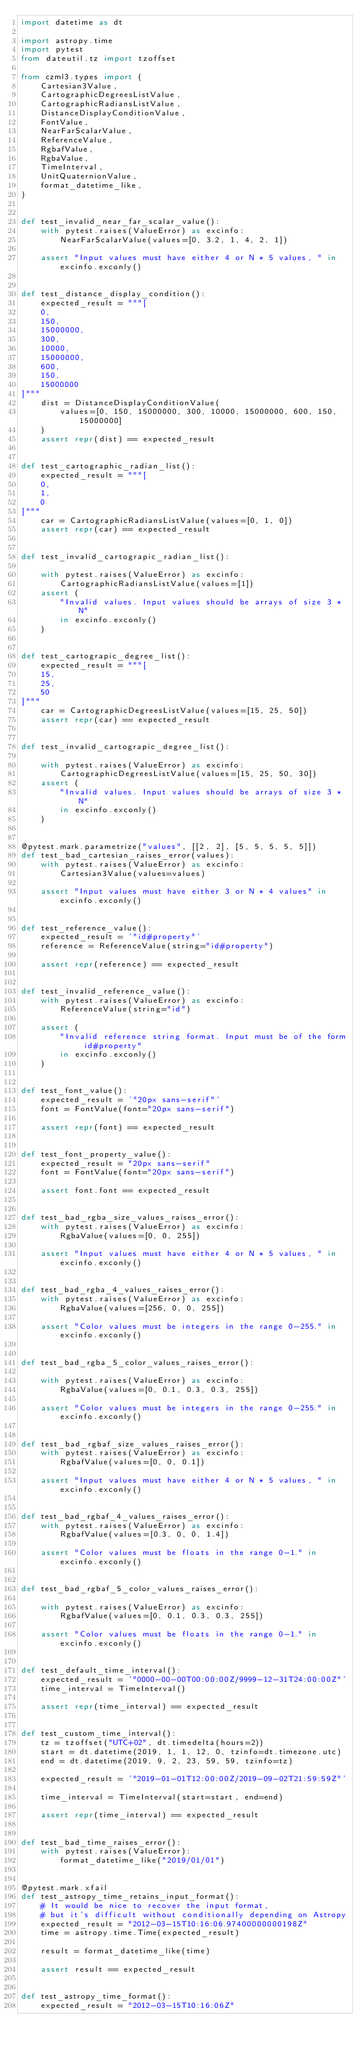Convert code to text. <code><loc_0><loc_0><loc_500><loc_500><_Python_>import datetime as dt

import astropy.time
import pytest
from dateutil.tz import tzoffset

from czml3.types import (
    Cartesian3Value,
    CartographicDegreesListValue,
    CartographicRadiansListValue,
    DistanceDisplayConditionValue,
    FontValue,
    NearFarScalarValue,
    ReferenceValue,
    RgbafValue,
    RgbaValue,
    TimeInterval,
    UnitQuaternionValue,
    format_datetime_like,
)


def test_invalid_near_far_scalar_value():
    with pytest.raises(ValueError) as excinfo:
        NearFarScalarValue(values=[0, 3.2, 1, 4, 2, 1])

    assert "Input values must have either 4 or N * 5 values, " in excinfo.exconly()


def test_distance_display_condition():
    expected_result = """[
    0,
    150,
    15000000,
    300,
    10000,
    15000000,
    600,
    150,
    15000000
]"""
    dist = DistanceDisplayConditionValue(
        values=[0, 150, 15000000, 300, 10000, 15000000, 600, 150, 15000000]
    )
    assert repr(dist) == expected_result


def test_cartographic_radian_list():
    expected_result = """[
    0,
    1,
    0
]"""
    car = CartographicRadiansListValue(values=[0, 1, 0])
    assert repr(car) == expected_result


def test_invalid_cartograpic_radian_list():

    with pytest.raises(ValueError) as excinfo:
        CartographicRadiansListValue(values=[1])
    assert (
        "Invalid values. Input values should be arrays of size 3 * N"
        in excinfo.exconly()
    )


def test_cartograpic_degree_list():
    expected_result = """[
    15,
    25,
    50
]"""
    car = CartographicDegreesListValue(values=[15, 25, 50])
    assert repr(car) == expected_result


def test_invalid_cartograpic_degree_list():

    with pytest.raises(ValueError) as excinfo:
        CartographicDegreesListValue(values=[15, 25, 50, 30])
    assert (
        "Invalid values. Input values should be arrays of size 3 * N"
        in excinfo.exconly()
    )


@pytest.mark.parametrize("values", [[2, 2], [5, 5, 5, 5, 5]])
def test_bad_cartesian_raises_error(values):
    with pytest.raises(ValueError) as excinfo:
        Cartesian3Value(values=values)

    assert "Input values must have either 3 or N * 4 values" in excinfo.exconly()


def test_reference_value():
    expected_result = '"id#property"'
    reference = ReferenceValue(string="id#property")

    assert repr(reference) == expected_result


def test_invalid_reference_value():
    with pytest.raises(ValueError) as excinfo:
        ReferenceValue(string="id")

    assert (
        "Invalid reference string format. Input must be of the form id#property"
        in excinfo.exconly()
    )


def test_font_value():
    expected_result = '"20px sans-serif"'
    font = FontValue(font="20px sans-serif")

    assert repr(font) == expected_result


def test_font_property_value():
    expected_result = "20px sans-serif"
    font = FontValue(font="20px sans-serif")

    assert font.font == expected_result


def test_bad_rgba_size_values_raises_error():
    with pytest.raises(ValueError) as excinfo:
        RgbaValue(values=[0, 0, 255])

    assert "Input values must have either 4 or N * 5 values, " in excinfo.exconly()


def test_bad_rgba_4_values_raises_error():
    with pytest.raises(ValueError) as excinfo:
        RgbaValue(values=[256, 0, 0, 255])

    assert "Color values must be integers in the range 0-255." in excinfo.exconly()


def test_bad_rgba_5_color_values_raises_error():

    with pytest.raises(ValueError) as excinfo:
        RgbaValue(values=[0, 0.1, 0.3, 0.3, 255])

    assert "Color values must be integers in the range 0-255." in excinfo.exconly()


def test_bad_rgbaf_size_values_raises_error():
    with pytest.raises(ValueError) as excinfo:
        RgbafValue(values=[0, 0, 0.1])

    assert "Input values must have either 4 or N * 5 values, " in excinfo.exconly()


def test_bad_rgbaf_4_values_raises_error():
    with pytest.raises(ValueError) as excinfo:
        RgbafValue(values=[0.3, 0, 0, 1.4])

    assert "Color values must be floats in the range 0-1." in excinfo.exconly()


def test_bad_rgbaf_5_color_values_raises_error():

    with pytest.raises(ValueError) as excinfo:
        RgbafValue(values=[0, 0.1, 0.3, 0.3, 255])

    assert "Color values must be floats in the range 0-1." in excinfo.exconly()


def test_default_time_interval():
    expected_result = '"0000-00-00T00:00:00Z/9999-12-31T24:00:00Z"'
    time_interval = TimeInterval()

    assert repr(time_interval) == expected_result


def test_custom_time_interval():
    tz = tzoffset("UTC+02", dt.timedelta(hours=2))
    start = dt.datetime(2019, 1, 1, 12, 0, tzinfo=dt.timezone.utc)
    end = dt.datetime(2019, 9, 2, 23, 59, 59, tzinfo=tz)

    expected_result = '"2019-01-01T12:00:00Z/2019-09-02T21:59:59Z"'

    time_interval = TimeInterval(start=start, end=end)

    assert repr(time_interval) == expected_result


def test_bad_time_raises_error():
    with pytest.raises(ValueError):
        format_datetime_like("2019/01/01")


@pytest.mark.xfail
def test_astropy_time_retains_input_format():
    # It would be nice to recover the input format,
    # but it's difficult without conditionally depending on Astropy
    expected_result = "2012-03-15T10:16:06.97400000000198Z"
    time = astropy.time.Time(expected_result)

    result = format_datetime_like(time)

    assert result == expected_result


def test_astropy_time_format():
    expected_result = "2012-03-15T10:16:06Z"</code> 